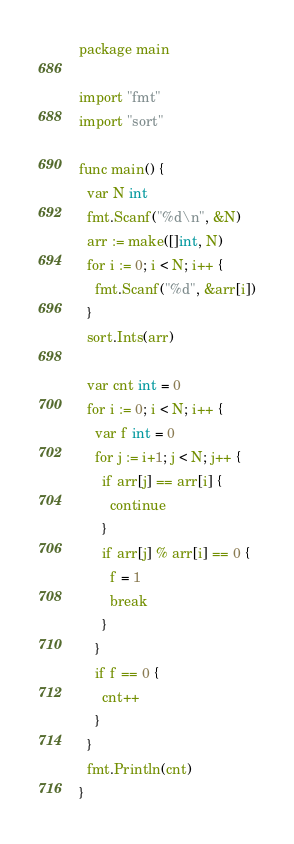<code> <loc_0><loc_0><loc_500><loc_500><_Go_>package main

import "fmt"
import "sort"

func main() {
  var N int
  fmt.Scanf("%d\n", &N)
  arr := make([]int, N)
  for i := 0; i < N; i++ {
    fmt.Scanf("%d", &arr[i])
  }
  sort.Ints(arr)
  
  var cnt int = 0
  for i := 0; i < N; i++ {
    var f int = 0
    for j := i+1; j < N; j++ {
      if arr[j] == arr[i] {
        continue
      }
      if arr[j] % arr[i] == 0 {
        f = 1
        break
      }
    }
    if f == 0 {
      cnt++
    }
  }
  fmt.Println(cnt)
}</code> 